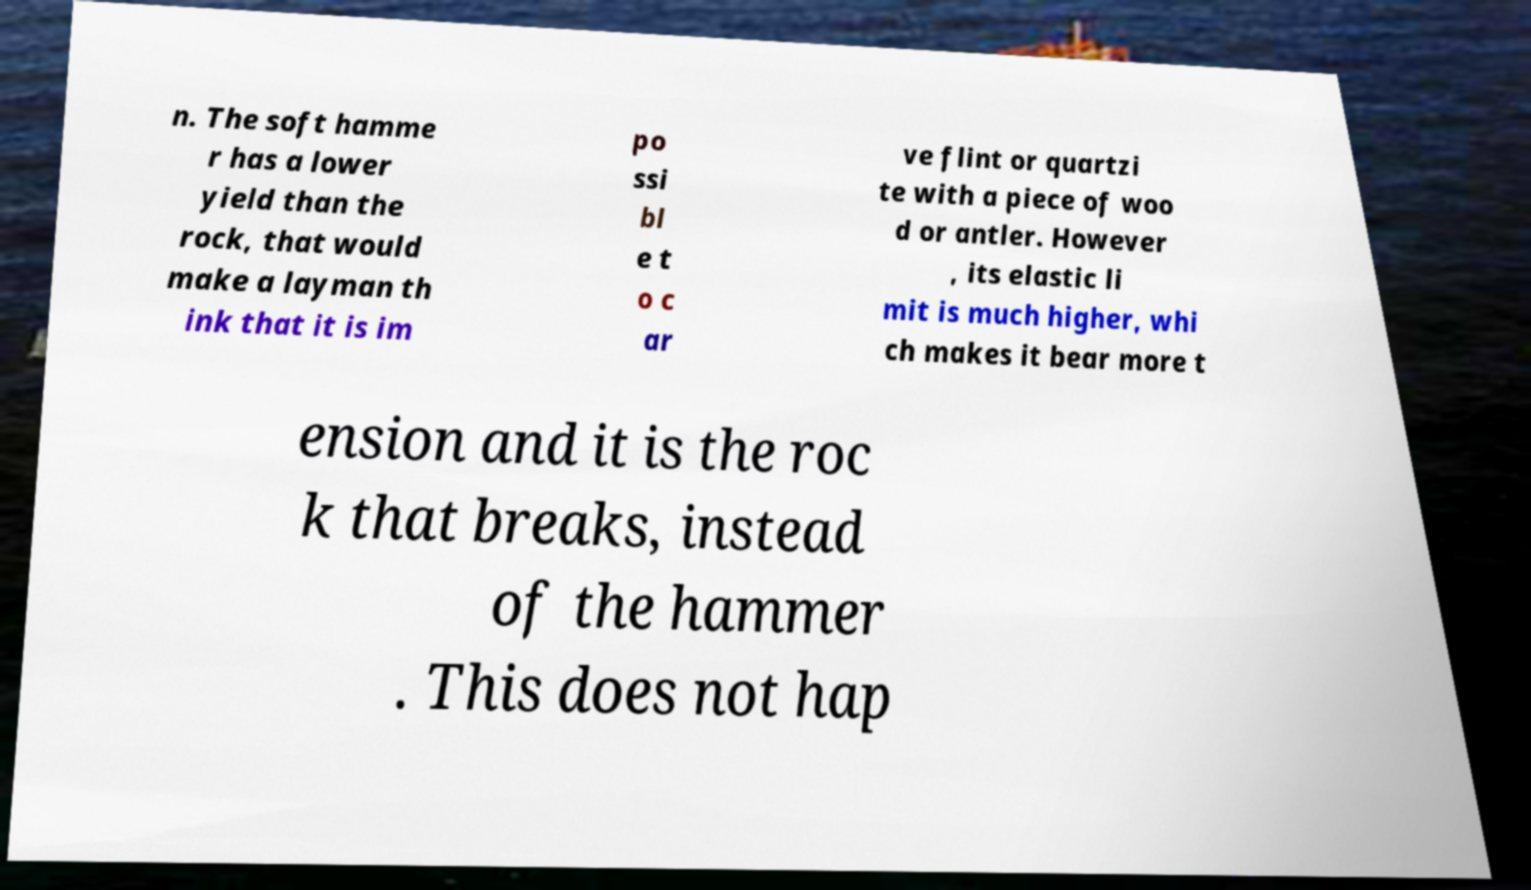For documentation purposes, I need the text within this image transcribed. Could you provide that? n. The soft hamme r has a lower yield than the rock, that would make a layman th ink that it is im po ssi bl e t o c ar ve flint or quartzi te with a piece of woo d or antler. However , its elastic li mit is much higher, whi ch makes it bear more t ension and it is the roc k that breaks, instead of the hammer . This does not hap 